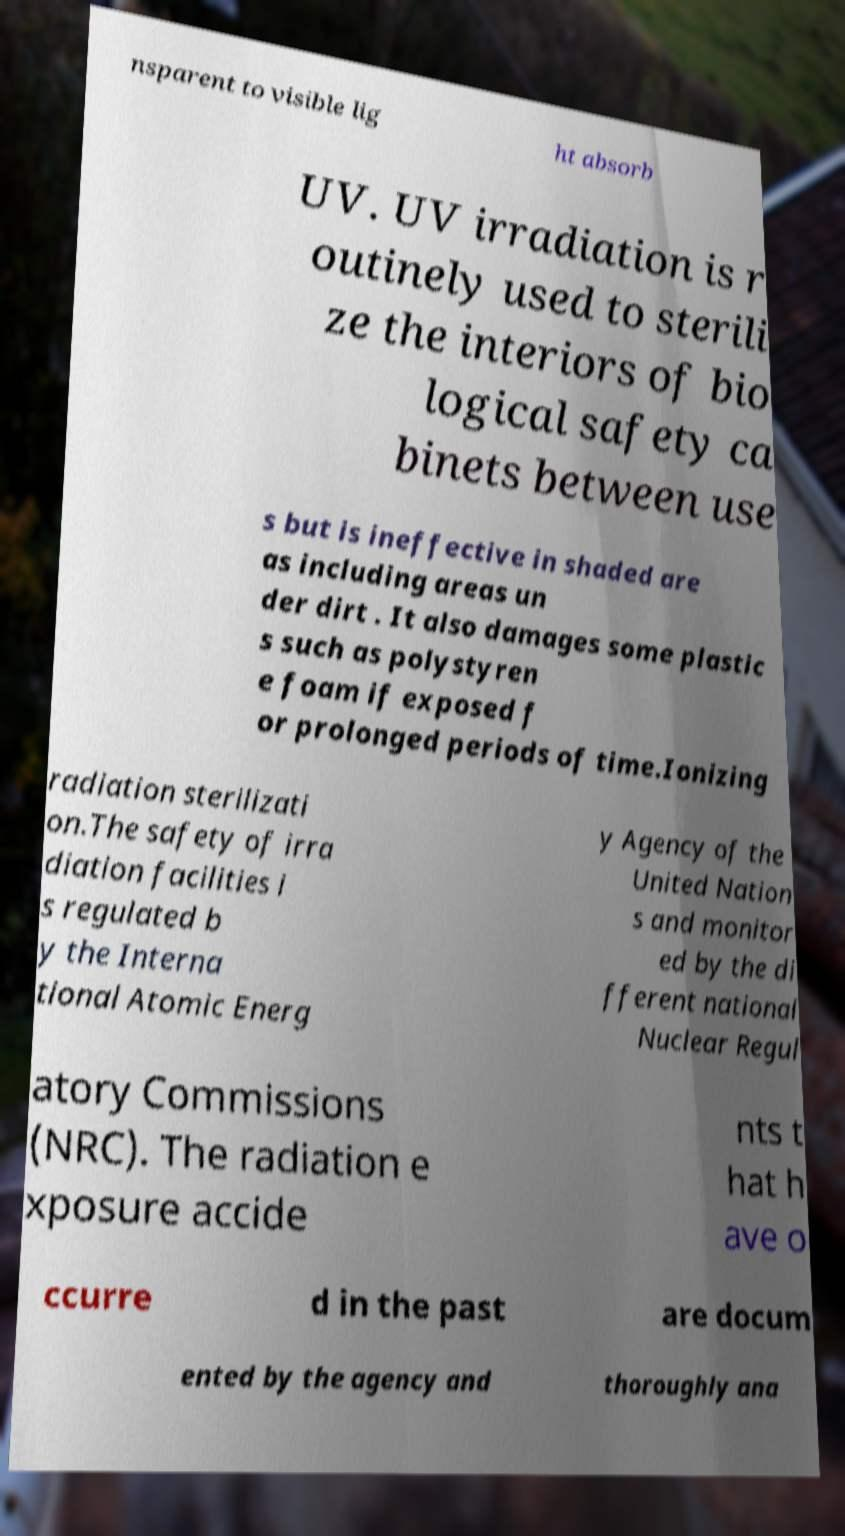I need the written content from this picture converted into text. Can you do that? nsparent to visible lig ht absorb UV. UV irradiation is r outinely used to sterili ze the interiors of bio logical safety ca binets between use s but is ineffective in shaded are as including areas un der dirt . It also damages some plastic s such as polystyren e foam if exposed f or prolonged periods of time.Ionizing radiation sterilizati on.The safety of irra diation facilities i s regulated b y the Interna tional Atomic Energ y Agency of the United Nation s and monitor ed by the di fferent national Nuclear Regul atory Commissions (NRC). The radiation e xposure accide nts t hat h ave o ccurre d in the past are docum ented by the agency and thoroughly ana 